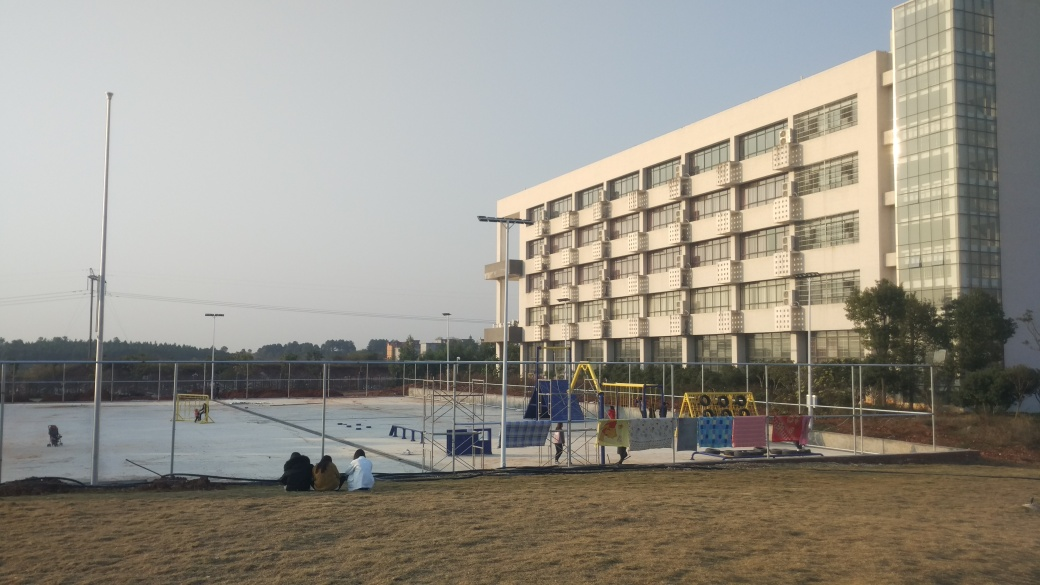What activities are shown in this image? The image depicts an outdoor setting with children playing in a playground full of colorful equipment. Additionally, there are people seated on the ground, suggesting a leisurely environment where one can relax and watch the activities unfold. 